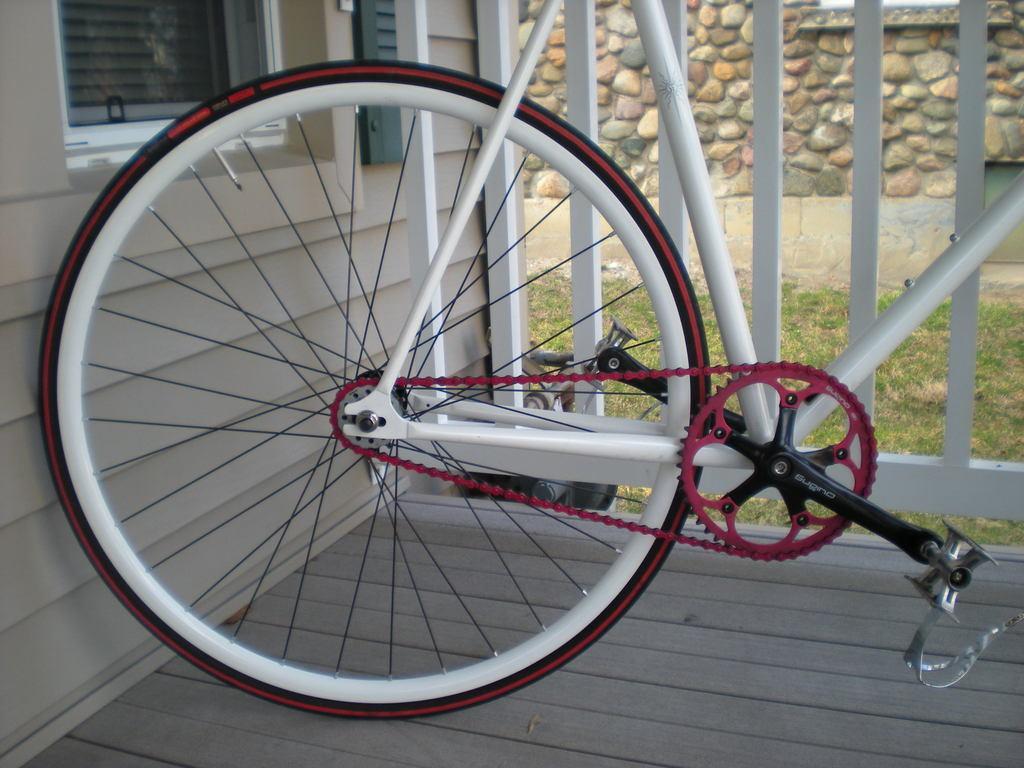Please provide a concise description of this image. In the image I can see a bicycle on wooden surface. In the background I can see a house, wooden fence, the grass and a wall. 